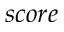Convert formula to latex. <formula><loc_0><loc_0><loc_500><loc_500>s c o r e</formula> 